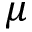Convert formula to latex. <formula><loc_0><loc_0><loc_500><loc_500>\mu</formula> 